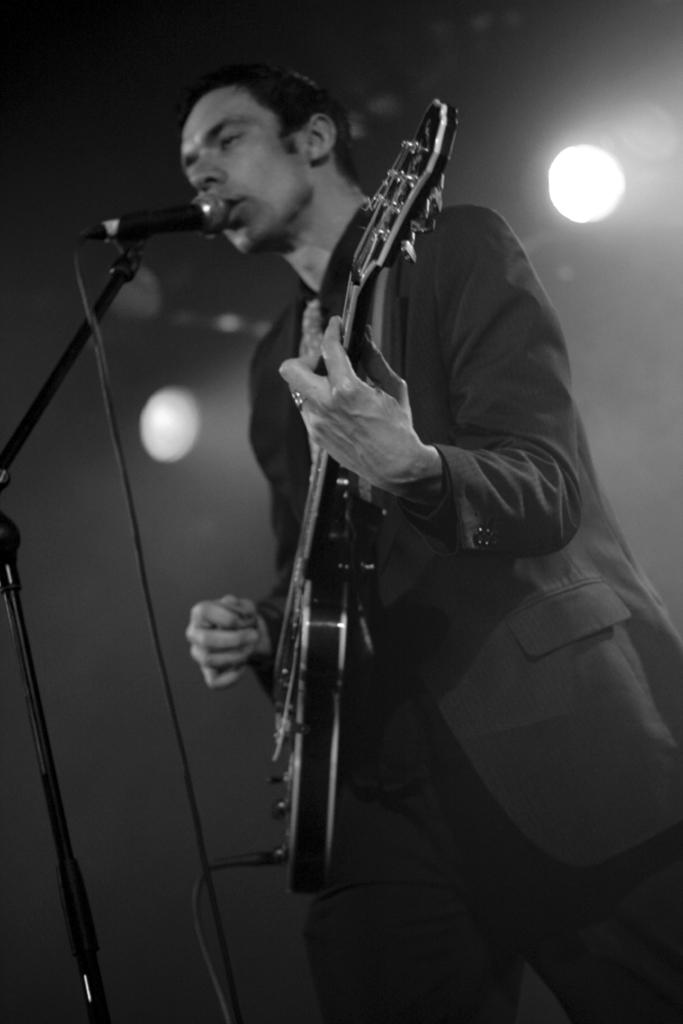What is the man in the image doing? The man is playing a guitar. What object is the man positioned in front of? The man is in front of a microphone. What type of clothing is the man wearing? The man is wearing a coat. What is the tendency of the room to affect the sound quality in the image? There is no room mentioned in the image, so it is not possible to determine the effect of a room on the sound quality. 